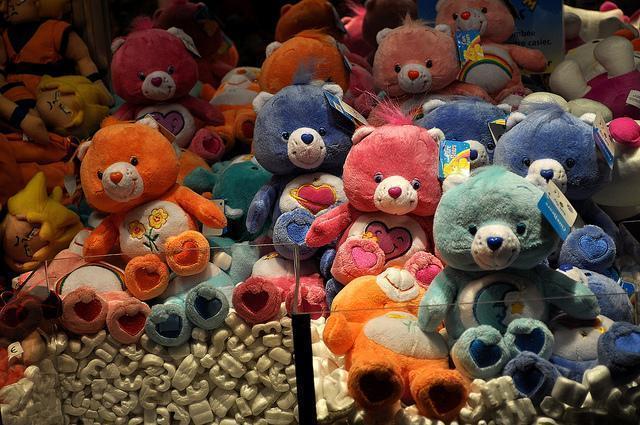What are the small white objects below the stuffed animals?
Indicate the correct response by choosing from the four available options to answer the question.
Options: Erasers, packing peanuts, balls, clips. Packing peanuts. 